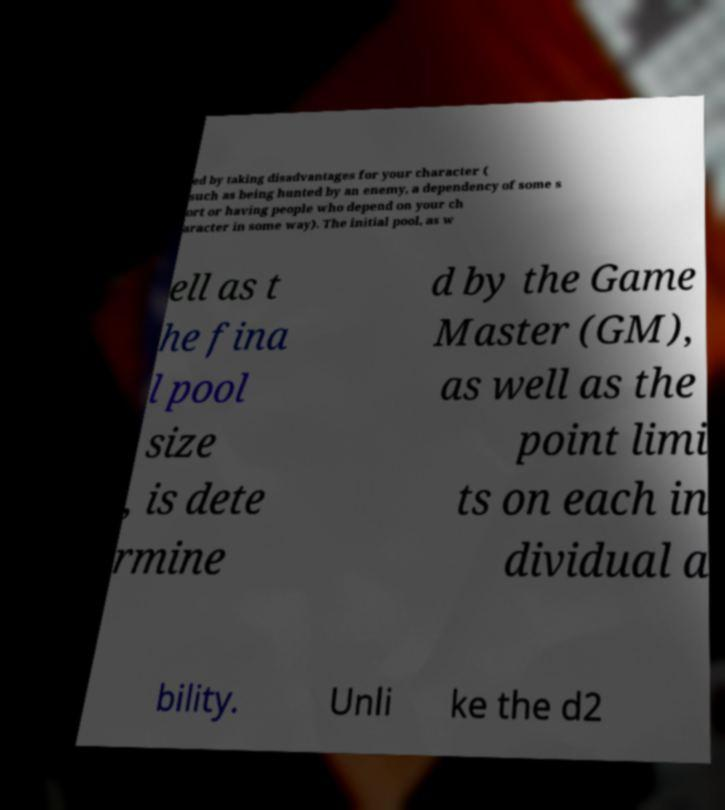Could you assist in decoding the text presented in this image and type it out clearly? ed by taking disadvantages for your character ( such as being hunted by an enemy, a dependency of some s ort or having people who depend on your ch aracter in some way). The initial pool, as w ell as t he fina l pool size , is dete rmine d by the Game Master (GM), as well as the point limi ts on each in dividual a bility. Unli ke the d2 